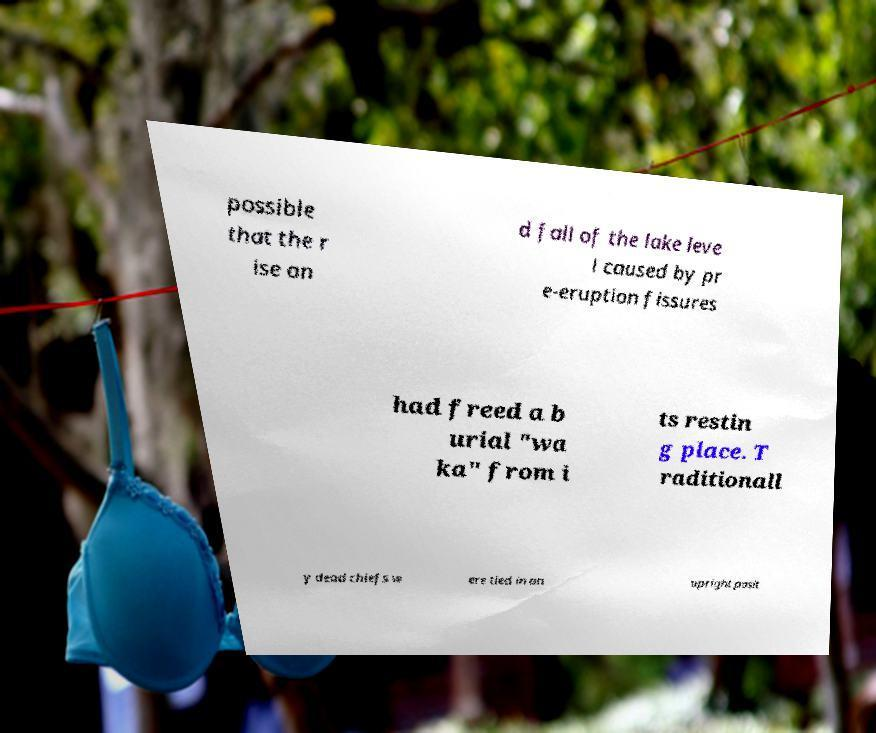There's text embedded in this image that I need extracted. Can you transcribe it verbatim? possible that the r ise an d fall of the lake leve l caused by pr e-eruption fissures had freed a b urial "wa ka" from i ts restin g place. T raditionall y dead chiefs w ere tied in an upright posit 